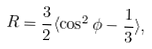Convert formula to latex. <formula><loc_0><loc_0><loc_500><loc_500>R = \frac { 3 } { 2 } \langle \cos ^ { 2 } \phi - \frac { 1 } { 3 } \rangle ,</formula> 